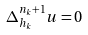<formula> <loc_0><loc_0><loc_500><loc_500>\Delta _ { h _ { k } } ^ { n _ { k } + 1 } u = 0</formula> 